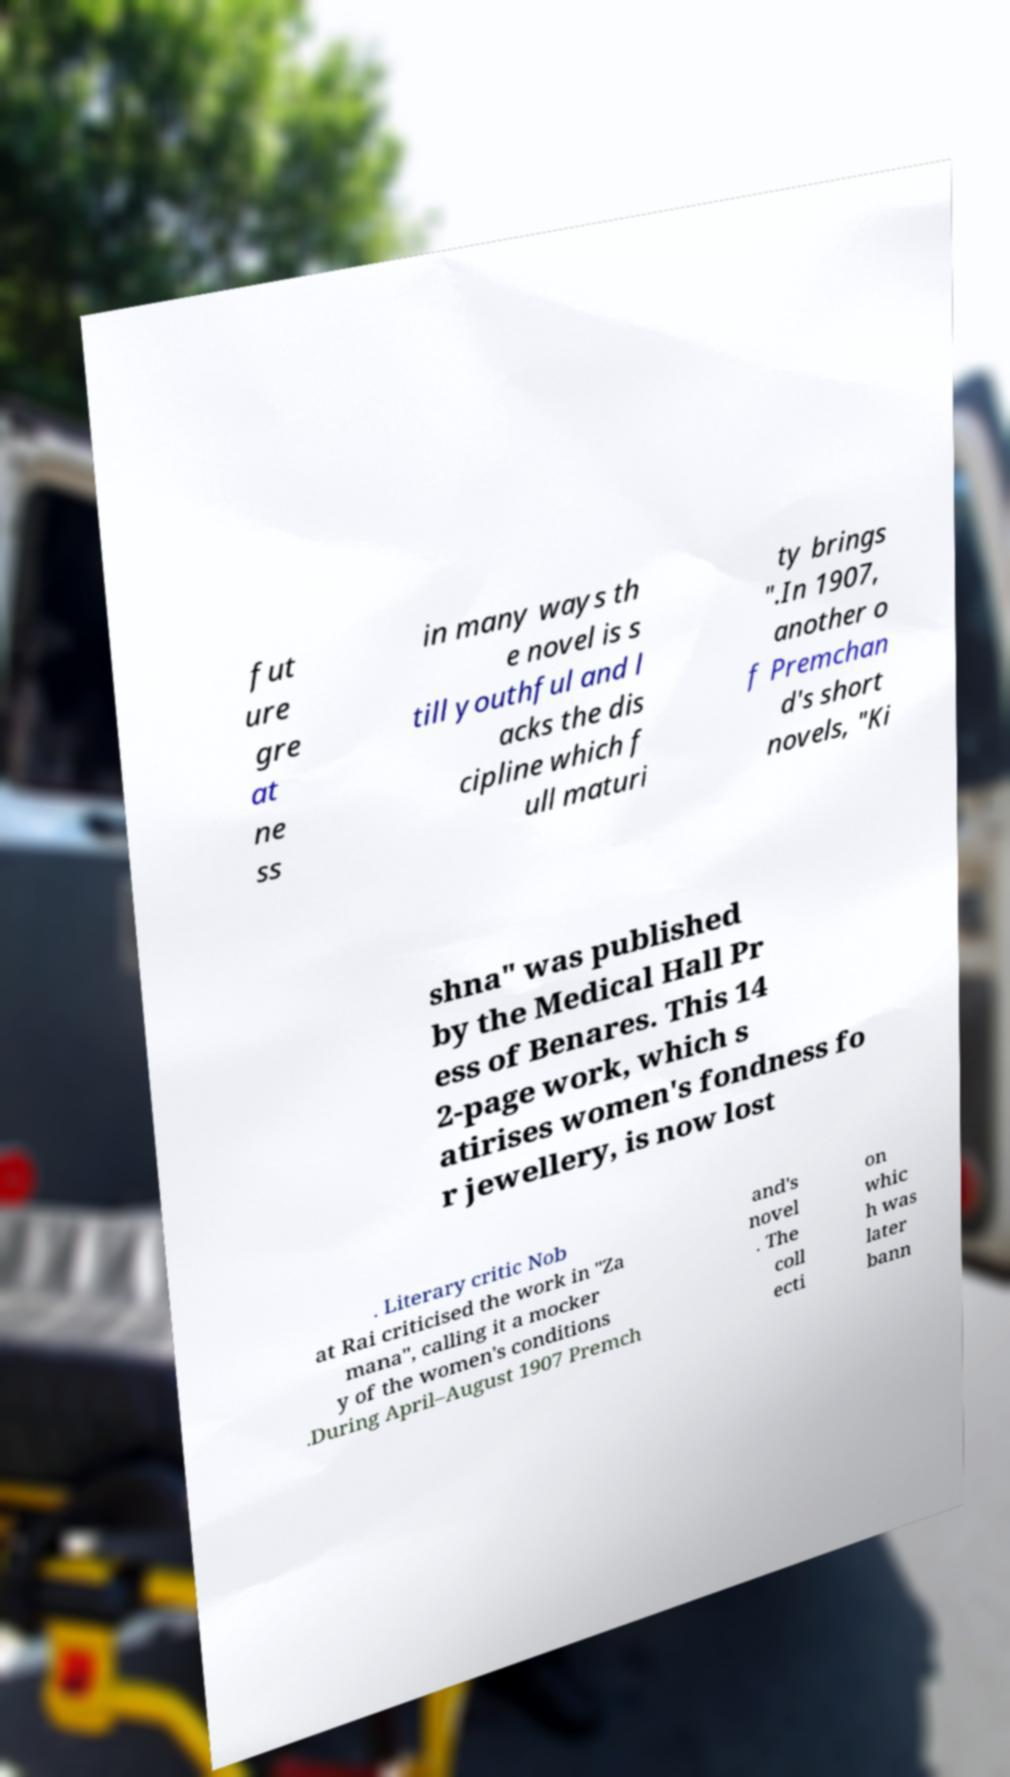Can you read and provide the text displayed in the image?This photo seems to have some interesting text. Can you extract and type it out for me? fut ure gre at ne ss in many ways th e novel is s till youthful and l acks the dis cipline which f ull maturi ty brings ".In 1907, another o f Premchan d's short novels, "Ki shna" was published by the Medical Hall Pr ess of Benares. This 14 2-page work, which s atirises women's fondness fo r jewellery, is now lost . Literary critic Nob at Rai criticised the work in "Za mana", calling it a mocker y of the women's conditions .During April–August 1907 Premch and's novel . The coll ecti on whic h was later bann 